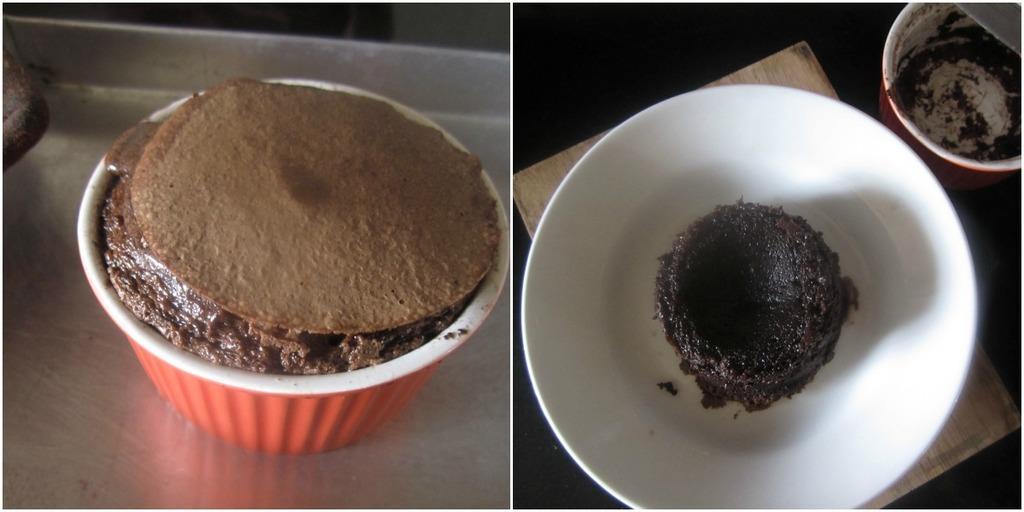In one or two sentences, can you explain what this image depicts? This is collage picture, in these picture we can see cups, bowl, cakes and objects. 